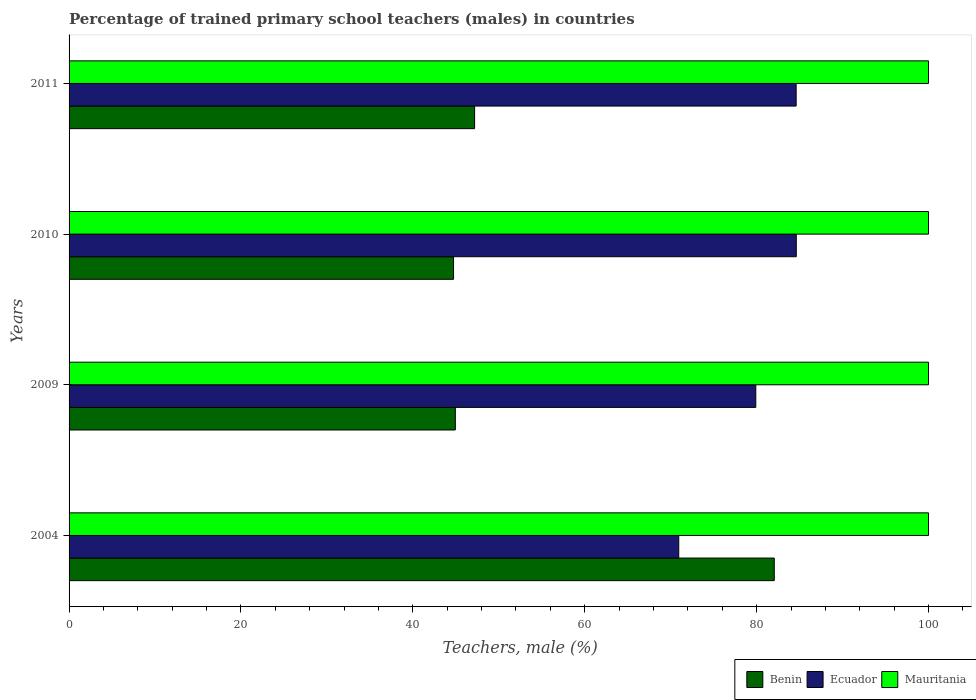How many different coloured bars are there?
Make the answer very short. 3. Are the number of bars on each tick of the Y-axis equal?
Your answer should be very brief. Yes. How many bars are there on the 1st tick from the top?
Offer a very short reply. 3. What is the label of the 1st group of bars from the top?
Keep it short and to the point. 2011. Across all years, what is the maximum percentage of trained primary school teachers (males) in Ecuador?
Offer a terse response. 84.61. In which year was the percentage of trained primary school teachers (males) in Ecuador maximum?
Give a very brief answer. 2010. What is the total percentage of trained primary school teachers (males) in Benin in the graph?
Your answer should be compact. 218.92. What is the difference between the percentage of trained primary school teachers (males) in Mauritania in 2010 and that in 2011?
Offer a very short reply. 0. What is the difference between the percentage of trained primary school teachers (males) in Ecuador in 2004 and the percentage of trained primary school teachers (males) in Mauritania in 2010?
Ensure brevity in your answer.  -29.06. What is the average percentage of trained primary school teachers (males) in Mauritania per year?
Your response must be concise. 100. In the year 2004, what is the difference between the percentage of trained primary school teachers (males) in Mauritania and percentage of trained primary school teachers (males) in Ecuador?
Make the answer very short. 29.06. In how many years, is the percentage of trained primary school teachers (males) in Benin greater than 4 %?
Ensure brevity in your answer.  4. What is the ratio of the percentage of trained primary school teachers (males) in Benin in 2004 to that in 2011?
Your answer should be compact. 1.74. Is the difference between the percentage of trained primary school teachers (males) in Mauritania in 2004 and 2009 greater than the difference between the percentage of trained primary school teachers (males) in Ecuador in 2004 and 2009?
Your answer should be very brief. Yes. What is the difference between the highest and the second highest percentage of trained primary school teachers (males) in Mauritania?
Offer a terse response. 0. What is the difference between the highest and the lowest percentage of trained primary school teachers (males) in Mauritania?
Your answer should be compact. 0. Is the sum of the percentage of trained primary school teachers (males) in Ecuador in 2004 and 2011 greater than the maximum percentage of trained primary school teachers (males) in Mauritania across all years?
Make the answer very short. Yes. What does the 3rd bar from the top in 2009 represents?
Offer a terse response. Benin. What does the 3rd bar from the bottom in 2004 represents?
Your answer should be compact. Mauritania. Is it the case that in every year, the sum of the percentage of trained primary school teachers (males) in Benin and percentage of trained primary school teachers (males) in Ecuador is greater than the percentage of trained primary school teachers (males) in Mauritania?
Your response must be concise. Yes. Are all the bars in the graph horizontal?
Your response must be concise. Yes. Are the values on the major ticks of X-axis written in scientific E-notation?
Offer a very short reply. No. Does the graph contain grids?
Offer a terse response. No. What is the title of the graph?
Your response must be concise. Percentage of trained primary school teachers (males) in countries. What is the label or title of the X-axis?
Make the answer very short. Teachers, male (%). What is the Teachers, male (%) of Benin in 2004?
Your answer should be compact. 82.05. What is the Teachers, male (%) in Ecuador in 2004?
Your answer should be very brief. 70.94. What is the Teachers, male (%) of Mauritania in 2004?
Provide a succinct answer. 100. What is the Teachers, male (%) in Benin in 2009?
Ensure brevity in your answer.  44.94. What is the Teachers, male (%) of Ecuador in 2009?
Make the answer very short. 79.9. What is the Teachers, male (%) in Benin in 2010?
Make the answer very short. 44.74. What is the Teachers, male (%) in Ecuador in 2010?
Ensure brevity in your answer.  84.61. What is the Teachers, male (%) of Mauritania in 2010?
Give a very brief answer. 100. What is the Teachers, male (%) in Benin in 2011?
Your answer should be compact. 47.19. What is the Teachers, male (%) of Ecuador in 2011?
Keep it short and to the point. 84.6. What is the Teachers, male (%) in Mauritania in 2011?
Provide a succinct answer. 100. Across all years, what is the maximum Teachers, male (%) of Benin?
Give a very brief answer. 82.05. Across all years, what is the maximum Teachers, male (%) of Ecuador?
Offer a very short reply. 84.61. Across all years, what is the maximum Teachers, male (%) of Mauritania?
Give a very brief answer. 100. Across all years, what is the minimum Teachers, male (%) of Benin?
Make the answer very short. 44.74. Across all years, what is the minimum Teachers, male (%) of Ecuador?
Your answer should be compact. 70.94. What is the total Teachers, male (%) in Benin in the graph?
Your response must be concise. 218.92. What is the total Teachers, male (%) in Ecuador in the graph?
Your response must be concise. 320.05. What is the difference between the Teachers, male (%) of Benin in 2004 and that in 2009?
Offer a very short reply. 37.11. What is the difference between the Teachers, male (%) of Ecuador in 2004 and that in 2009?
Make the answer very short. -8.96. What is the difference between the Teachers, male (%) in Benin in 2004 and that in 2010?
Provide a short and direct response. 37.32. What is the difference between the Teachers, male (%) of Ecuador in 2004 and that in 2010?
Ensure brevity in your answer.  -13.68. What is the difference between the Teachers, male (%) in Mauritania in 2004 and that in 2010?
Keep it short and to the point. 0. What is the difference between the Teachers, male (%) of Benin in 2004 and that in 2011?
Provide a short and direct response. 34.87. What is the difference between the Teachers, male (%) in Ecuador in 2004 and that in 2011?
Ensure brevity in your answer.  -13.66. What is the difference between the Teachers, male (%) in Mauritania in 2004 and that in 2011?
Provide a short and direct response. 0. What is the difference between the Teachers, male (%) in Benin in 2009 and that in 2010?
Make the answer very short. 0.21. What is the difference between the Teachers, male (%) in Ecuador in 2009 and that in 2010?
Your response must be concise. -4.71. What is the difference between the Teachers, male (%) in Mauritania in 2009 and that in 2010?
Your response must be concise. 0. What is the difference between the Teachers, male (%) in Benin in 2009 and that in 2011?
Keep it short and to the point. -2.24. What is the difference between the Teachers, male (%) of Ecuador in 2009 and that in 2011?
Offer a terse response. -4.7. What is the difference between the Teachers, male (%) in Benin in 2010 and that in 2011?
Your response must be concise. -2.45. What is the difference between the Teachers, male (%) of Ecuador in 2010 and that in 2011?
Provide a succinct answer. 0.02. What is the difference between the Teachers, male (%) in Mauritania in 2010 and that in 2011?
Keep it short and to the point. 0. What is the difference between the Teachers, male (%) of Benin in 2004 and the Teachers, male (%) of Ecuador in 2009?
Provide a succinct answer. 2.15. What is the difference between the Teachers, male (%) of Benin in 2004 and the Teachers, male (%) of Mauritania in 2009?
Your answer should be compact. -17.95. What is the difference between the Teachers, male (%) in Ecuador in 2004 and the Teachers, male (%) in Mauritania in 2009?
Offer a terse response. -29.06. What is the difference between the Teachers, male (%) in Benin in 2004 and the Teachers, male (%) in Ecuador in 2010?
Give a very brief answer. -2.56. What is the difference between the Teachers, male (%) in Benin in 2004 and the Teachers, male (%) in Mauritania in 2010?
Ensure brevity in your answer.  -17.95. What is the difference between the Teachers, male (%) of Ecuador in 2004 and the Teachers, male (%) of Mauritania in 2010?
Give a very brief answer. -29.06. What is the difference between the Teachers, male (%) of Benin in 2004 and the Teachers, male (%) of Ecuador in 2011?
Offer a very short reply. -2.55. What is the difference between the Teachers, male (%) of Benin in 2004 and the Teachers, male (%) of Mauritania in 2011?
Your answer should be very brief. -17.95. What is the difference between the Teachers, male (%) of Ecuador in 2004 and the Teachers, male (%) of Mauritania in 2011?
Give a very brief answer. -29.06. What is the difference between the Teachers, male (%) of Benin in 2009 and the Teachers, male (%) of Ecuador in 2010?
Your response must be concise. -39.67. What is the difference between the Teachers, male (%) of Benin in 2009 and the Teachers, male (%) of Mauritania in 2010?
Ensure brevity in your answer.  -55.06. What is the difference between the Teachers, male (%) of Ecuador in 2009 and the Teachers, male (%) of Mauritania in 2010?
Your answer should be compact. -20.1. What is the difference between the Teachers, male (%) of Benin in 2009 and the Teachers, male (%) of Ecuador in 2011?
Give a very brief answer. -39.66. What is the difference between the Teachers, male (%) of Benin in 2009 and the Teachers, male (%) of Mauritania in 2011?
Ensure brevity in your answer.  -55.06. What is the difference between the Teachers, male (%) of Ecuador in 2009 and the Teachers, male (%) of Mauritania in 2011?
Ensure brevity in your answer.  -20.1. What is the difference between the Teachers, male (%) of Benin in 2010 and the Teachers, male (%) of Ecuador in 2011?
Provide a short and direct response. -39.86. What is the difference between the Teachers, male (%) of Benin in 2010 and the Teachers, male (%) of Mauritania in 2011?
Ensure brevity in your answer.  -55.26. What is the difference between the Teachers, male (%) in Ecuador in 2010 and the Teachers, male (%) in Mauritania in 2011?
Offer a terse response. -15.39. What is the average Teachers, male (%) in Benin per year?
Give a very brief answer. 54.73. What is the average Teachers, male (%) of Ecuador per year?
Ensure brevity in your answer.  80.01. In the year 2004, what is the difference between the Teachers, male (%) of Benin and Teachers, male (%) of Ecuador?
Provide a short and direct response. 11.11. In the year 2004, what is the difference between the Teachers, male (%) in Benin and Teachers, male (%) in Mauritania?
Keep it short and to the point. -17.95. In the year 2004, what is the difference between the Teachers, male (%) of Ecuador and Teachers, male (%) of Mauritania?
Offer a terse response. -29.06. In the year 2009, what is the difference between the Teachers, male (%) of Benin and Teachers, male (%) of Ecuador?
Offer a terse response. -34.96. In the year 2009, what is the difference between the Teachers, male (%) of Benin and Teachers, male (%) of Mauritania?
Provide a succinct answer. -55.06. In the year 2009, what is the difference between the Teachers, male (%) in Ecuador and Teachers, male (%) in Mauritania?
Ensure brevity in your answer.  -20.1. In the year 2010, what is the difference between the Teachers, male (%) in Benin and Teachers, male (%) in Ecuador?
Make the answer very short. -39.88. In the year 2010, what is the difference between the Teachers, male (%) of Benin and Teachers, male (%) of Mauritania?
Keep it short and to the point. -55.26. In the year 2010, what is the difference between the Teachers, male (%) of Ecuador and Teachers, male (%) of Mauritania?
Make the answer very short. -15.39. In the year 2011, what is the difference between the Teachers, male (%) in Benin and Teachers, male (%) in Ecuador?
Keep it short and to the point. -37.41. In the year 2011, what is the difference between the Teachers, male (%) of Benin and Teachers, male (%) of Mauritania?
Provide a short and direct response. -52.81. In the year 2011, what is the difference between the Teachers, male (%) in Ecuador and Teachers, male (%) in Mauritania?
Your answer should be compact. -15.4. What is the ratio of the Teachers, male (%) in Benin in 2004 to that in 2009?
Keep it short and to the point. 1.83. What is the ratio of the Teachers, male (%) of Ecuador in 2004 to that in 2009?
Make the answer very short. 0.89. What is the ratio of the Teachers, male (%) in Mauritania in 2004 to that in 2009?
Make the answer very short. 1. What is the ratio of the Teachers, male (%) in Benin in 2004 to that in 2010?
Provide a succinct answer. 1.83. What is the ratio of the Teachers, male (%) in Ecuador in 2004 to that in 2010?
Provide a succinct answer. 0.84. What is the ratio of the Teachers, male (%) in Mauritania in 2004 to that in 2010?
Your answer should be very brief. 1. What is the ratio of the Teachers, male (%) in Benin in 2004 to that in 2011?
Provide a short and direct response. 1.74. What is the ratio of the Teachers, male (%) of Ecuador in 2004 to that in 2011?
Give a very brief answer. 0.84. What is the ratio of the Teachers, male (%) of Ecuador in 2009 to that in 2010?
Provide a succinct answer. 0.94. What is the ratio of the Teachers, male (%) in Benin in 2009 to that in 2011?
Your answer should be compact. 0.95. What is the ratio of the Teachers, male (%) in Ecuador in 2009 to that in 2011?
Your answer should be very brief. 0.94. What is the ratio of the Teachers, male (%) in Benin in 2010 to that in 2011?
Ensure brevity in your answer.  0.95. What is the difference between the highest and the second highest Teachers, male (%) in Benin?
Offer a very short reply. 34.87. What is the difference between the highest and the second highest Teachers, male (%) of Ecuador?
Your response must be concise. 0.02. What is the difference between the highest and the lowest Teachers, male (%) in Benin?
Offer a terse response. 37.32. What is the difference between the highest and the lowest Teachers, male (%) in Ecuador?
Ensure brevity in your answer.  13.68. What is the difference between the highest and the lowest Teachers, male (%) in Mauritania?
Keep it short and to the point. 0. 